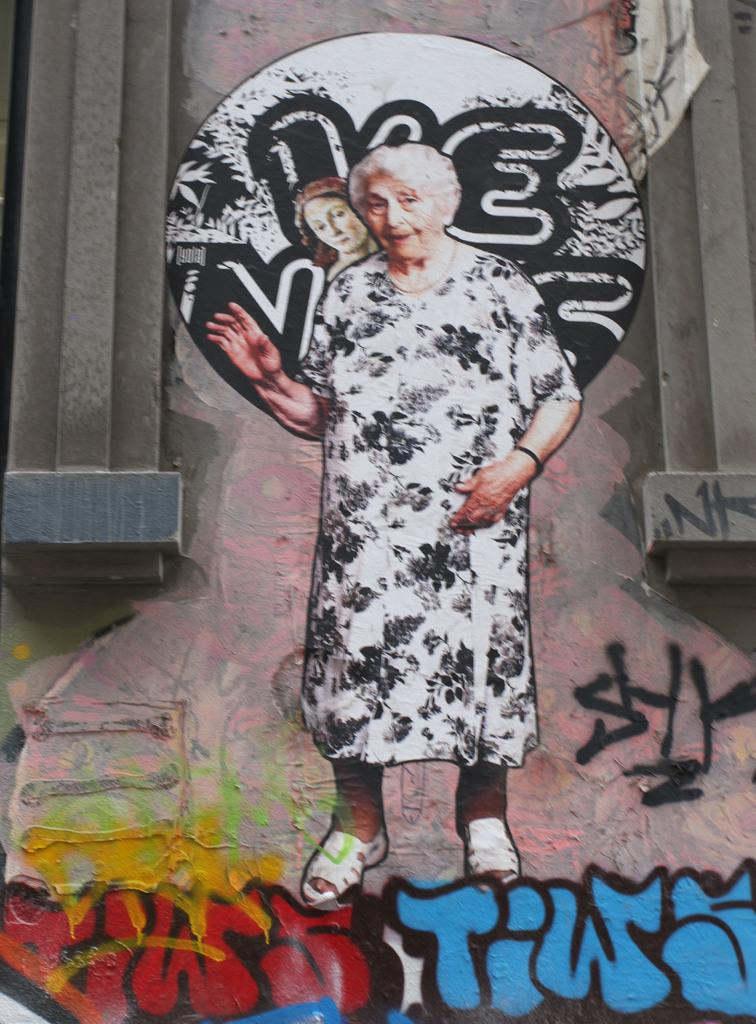What is the main subject of the graffiti image in the picture? The main subject of the graffiti image in the picture is an old woman. Are there any other drawings or images in the picture? Yes, there are other drawings in the picture. What architectural features can be seen on either side of the graffiti wall? There are pillars on either side of the graffiti wall. What type of liquid is being poured over the graffiti wall in the image? There is no liquid being poured over the graffiti wall in the image. Can you provide an example of a similar graffiti image found in another location? The provided facts do not give information about other locations or similar graffiti images, so it is not possible to provide an example. 